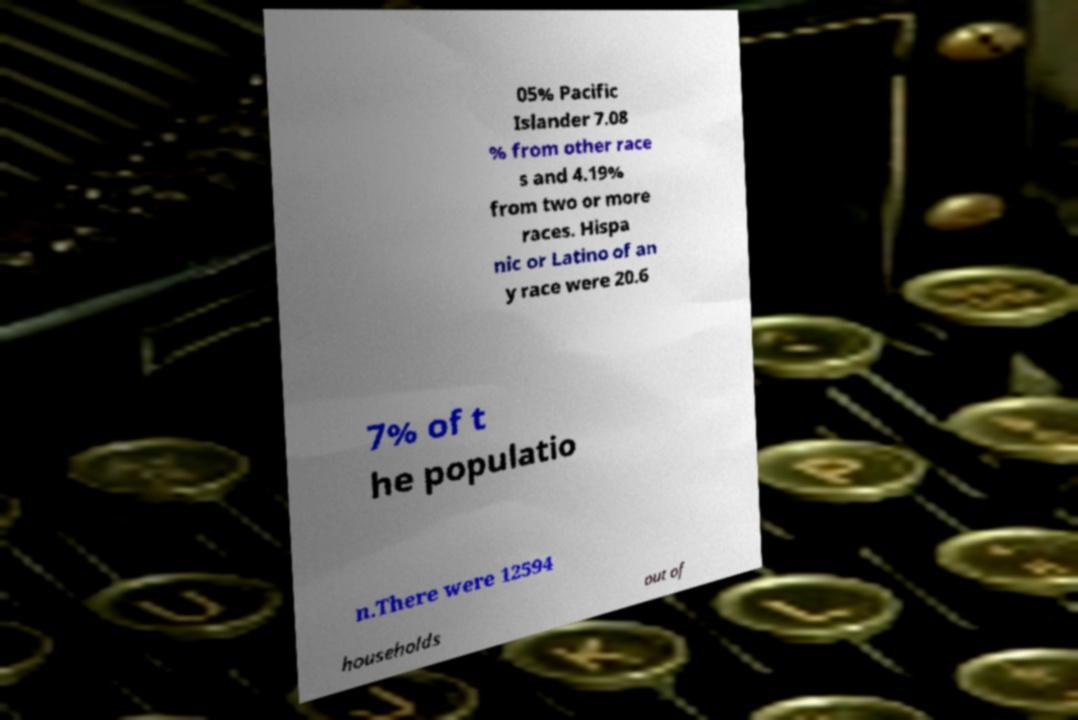There's text embedded in this image that I need extracted. Can you transcribe it verbatim? 05% Pacific Islander 7.08 % from other race s and 4.19% from two or more races. Hispa nic or Latino of an y race were 20.6 7% of t he populatio n.There were 12594 households out of 